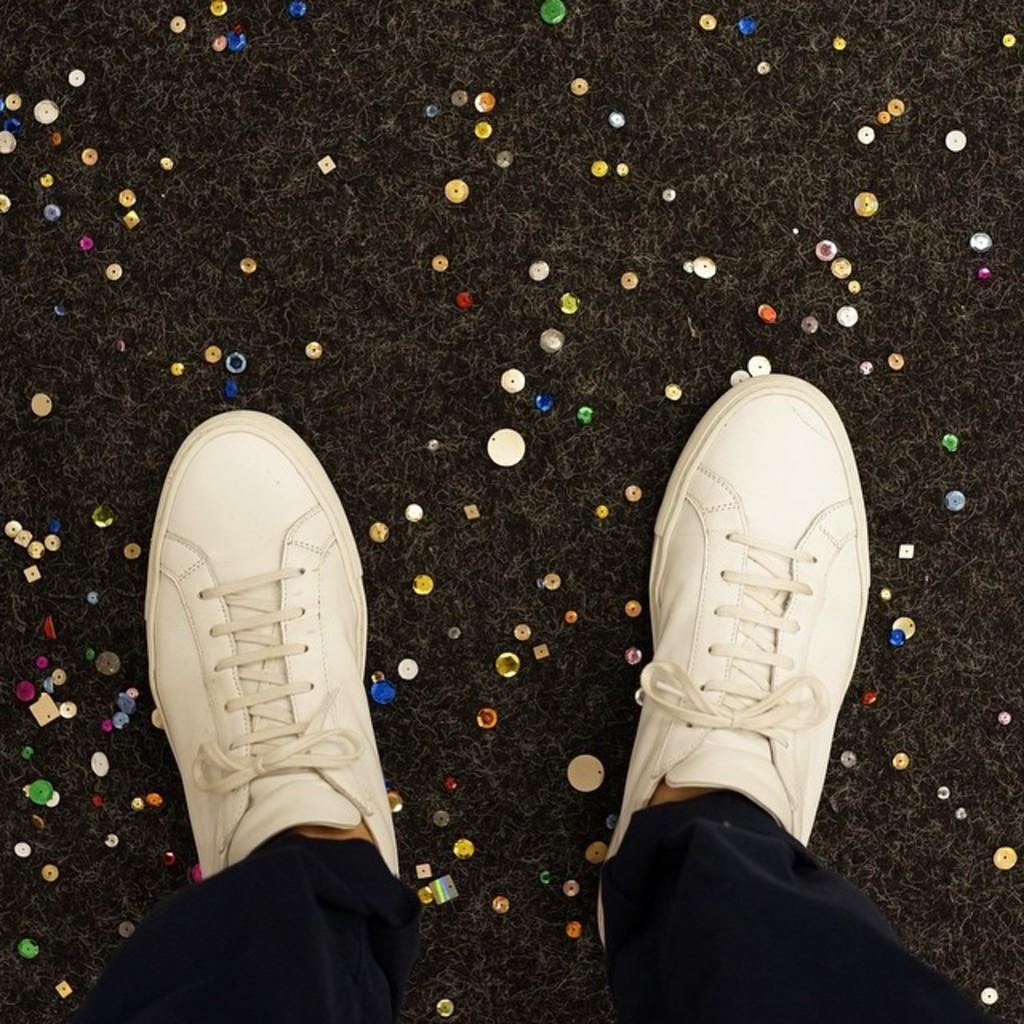Please provide a concise description of this image. At the bottom of the image we can see the person's legs and wearing the shoes, pant. In the background of the image we can see the carpet and decor. 